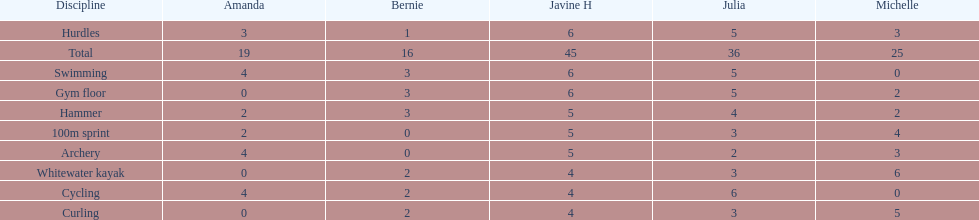What is the last discipline listed on this chart? 100m sprint. Can you parse all the data within this table? {'header': ['Discipline', 'Amanda', 'Bernie', 'Javine H', 'Julia', 'Michelle'], 'rows': [['Hurdles', '3', '1', '6', '5', '3'], ['Total', '19', '16', '45', '36', '25'], ['Swimming', '4', '3', '6', '5', '0'], ['Gym floor', '0', '3', '6', '5', '2'], ['Hammer', '2', '3', '5', '4', '2'], ['100m sprint', '2', '0', '5', '3', '4'], ['Archery', '4', '0', '5', '2', '3'], ['Whitewater kayak', '0', '2', '4', '3', '6'], ['Cycling', '4', '2', '4', '6', '0'], ['Curling', '0', '2', '4', '3', '5']]} 